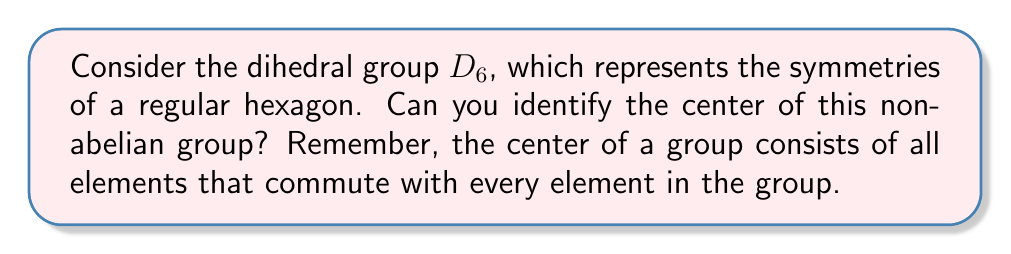Can you solve this math problem? Let's approach this step-by-step:

1) First, recall that $D_6$ has 12 elements: 6 rotations (including the identity) and 6 reflections.

2) The rotations in $D_6$ are:
   $e$ (identity), $r$ (60° rotation), $r^2$ (120° rotation), $r^3$ (180° rotation), $r^4$ (240° rotation), $r^5$ (300° rotation)

3) The reflections in $D_6$ are:
   $s, sr, sr^2, sr^3, sr^4, sr^5$

4) To be in the center, an element must commute with all other elements.

5) The identity $e$ always commutes with everything, so it's always in the center.

6) Let's check if $r^3$ (180° rotation) commutes with everything:
   - It commutes with all rotations (rotations are always commutative with each other).
   - For any reflection $sr^i$: $r^3(sr^i) = sr^{i+3} = (sr^i)r^3$
   So $r^3$ also commutes with all reflections.

7) All other rotations do not commute with the reflections, and reflections do not commute with each other or with rotations (except $r^3$).

Therefore, the center of $D_6$ consists of $\{e, r^3\}$.
Answer: The center of $D_6$ is $\{e, r^3\}$. 